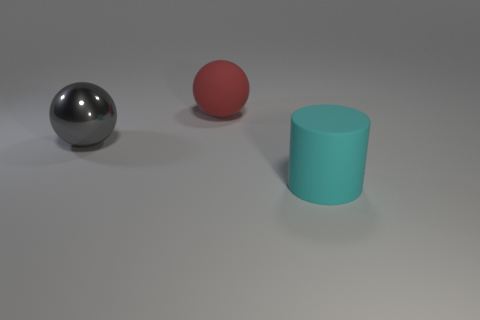What number of other metal spheres are the same size as the metal ball?
Offer a very short reply. 0. The large rubber object on the left side of the thing in front of the large gray metallic ball is what color?
Give a very brief answer. Red. Are any red spheres visible?
Give a very brief answer. Yes. Do the red matte thing and the cyan matte object have the same shape?
Make the answer very short. No. There is a large matte object in front of the large gray metallic sphere; how many cylinders are on the left side of it?
Your answer should be compact. 0. What number of big things are behind the big cyan cylinder and right of the big red matte thing?
Your answer should be compact. 0. How many things are either big shiny things or large cyan matte cylinders to the right of the gray object?
Offer a terse response. 2. There is a sphere that is made of the same material as the large cyan object; what is its size?
Offer a terse response. Large. There is a large matte object behind the cyan rubber object that is right of the gray metal ball; what is its shape?
Offer a very short reply. Sphere. How many red things are either rubber things or large cylinders?
Your answer should be compact. 1. 